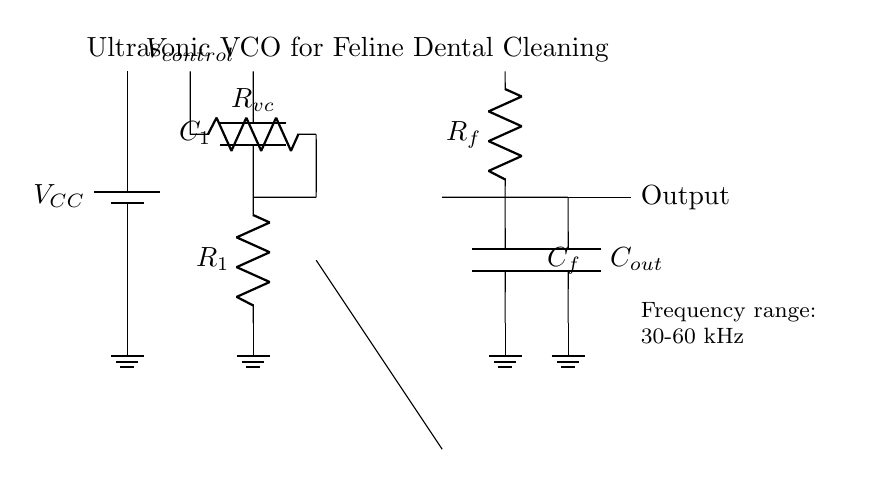What is the primary function of the circuit? The circuit functions as a voltage-controlled oscillator (VCO) designed to generate ultrasonic frequencies for dental cleaning in felines.
Answer: voltage-controlled oscillator What is the frequency range indicated? The frequency range mentioned in the diagram is from 30 kHz to 60 kHz, which is suitable for ultrasonic applications.
Answer: 30-60 kHz Which component is responsible for voltage control? The component responsible for voltage control is labeled as Rvc in the diagram, which allows the user to adjust the control voltage that influences the oscillator's output frequency.
Answer: Rvc Where is the output of the circuit located? The output can be found at the right side of the circuit, where it exits through a capacitor labeled Cout and is indicated to proceed as the output signal.
Answer: right side How does the feedback network affect the oscillator? The feedback network, composed of Rf and Cf, stabilizes the oscillation frequency and ensures consistent operation by providing feedback to the oscillator core.
Answer: stabilizes oscillation What type of capacitor is used at the output of this circuit? The capacitor connected at the output is labeled Cout, indicating its role in shaping the output signal by filtering high-frequency components.
Answer: Cout 